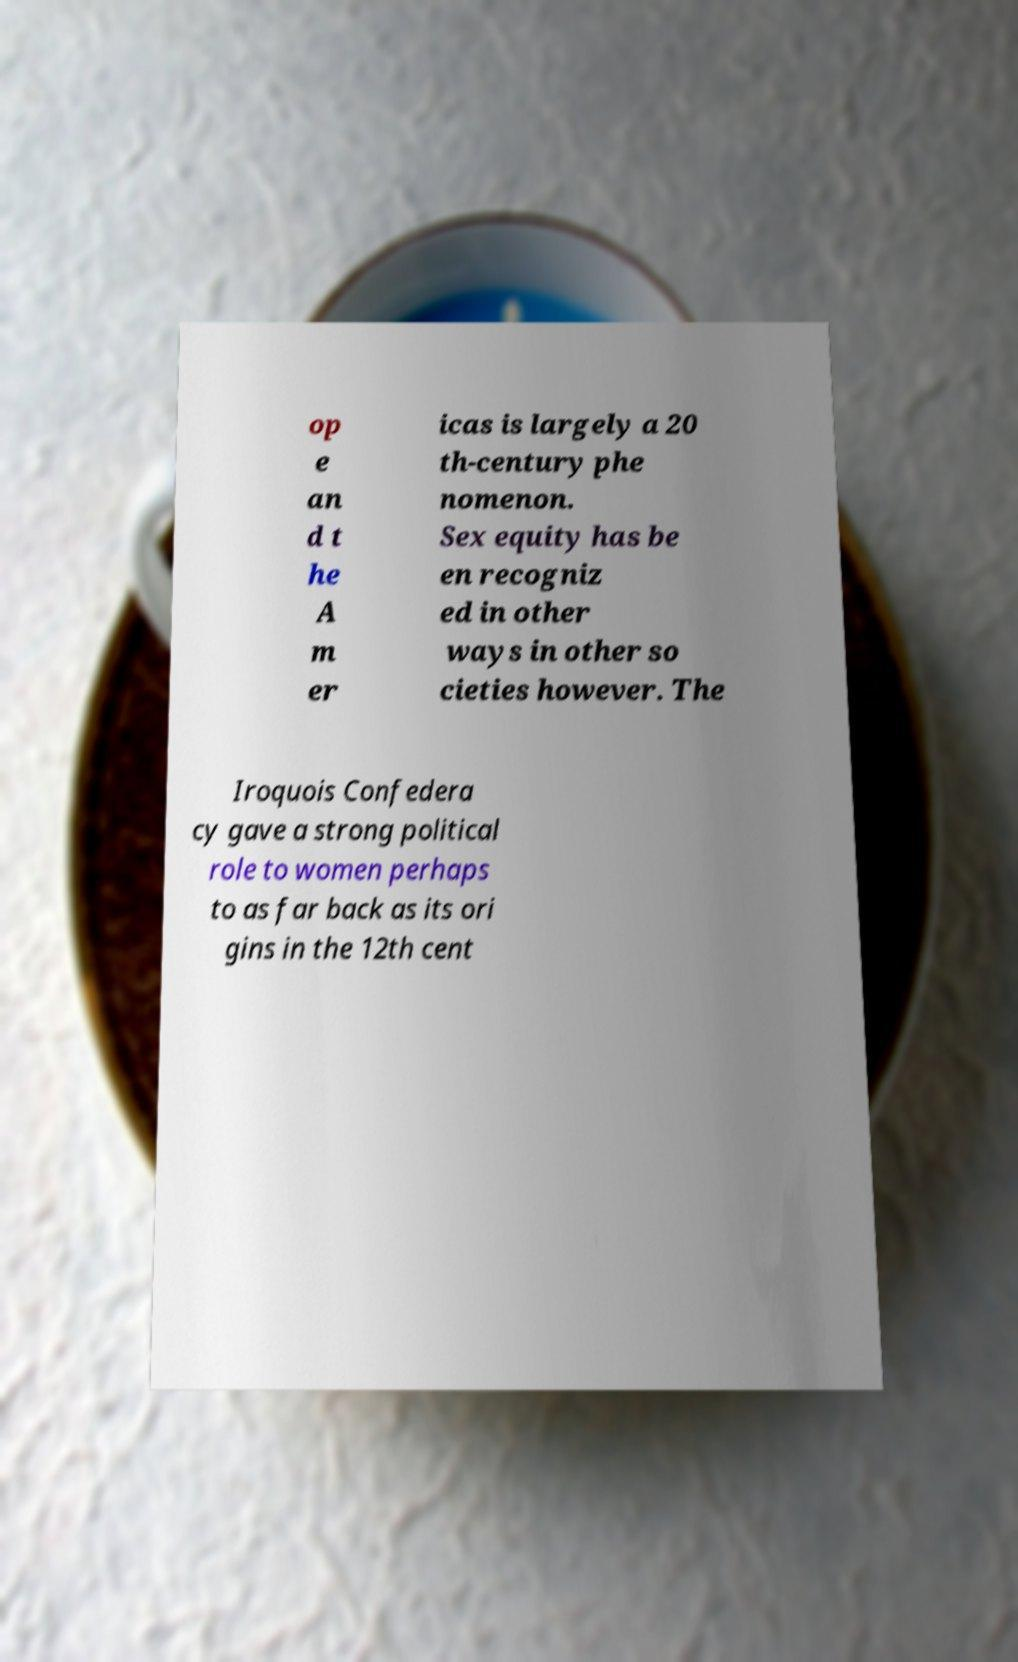Could you extract and type out the text from this image? op e an d t he A m er icas is largely a 20 th-century phe nomenon. Sex equity has be en recogniz ed in other ways in other so cieties however. The Iroquois Confedera cy gave a strong political role to women perhaps to as far back as its ori gins in the 12th cent 